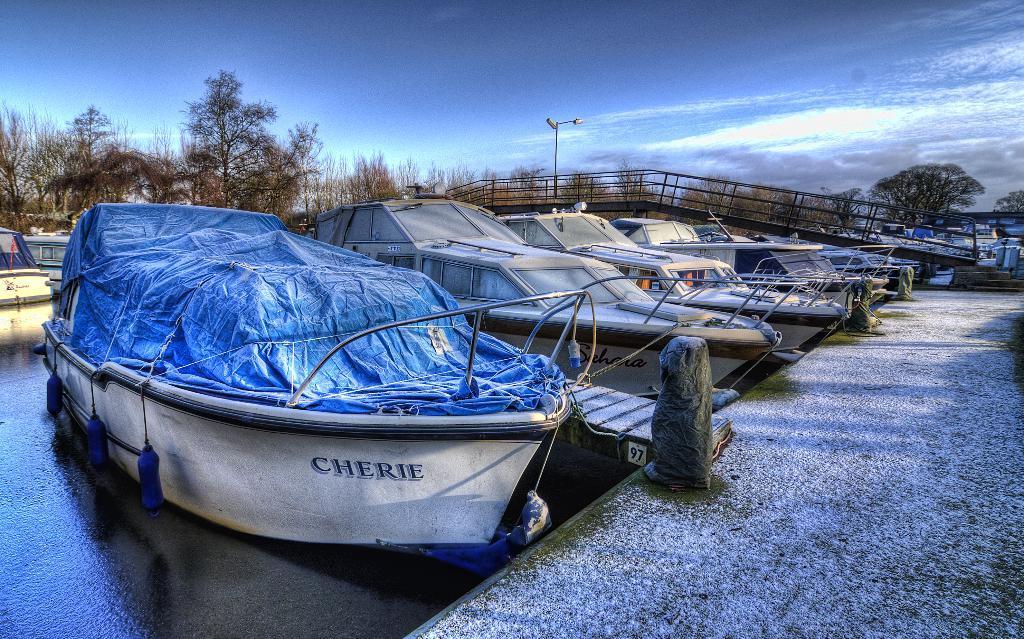Please provide a concise description of this image. In this image I can see many boats in water, they are in white and gray color. I can also see a blue color cover in the boat, at back there are trees, light pole and sky is in white and blue color. 